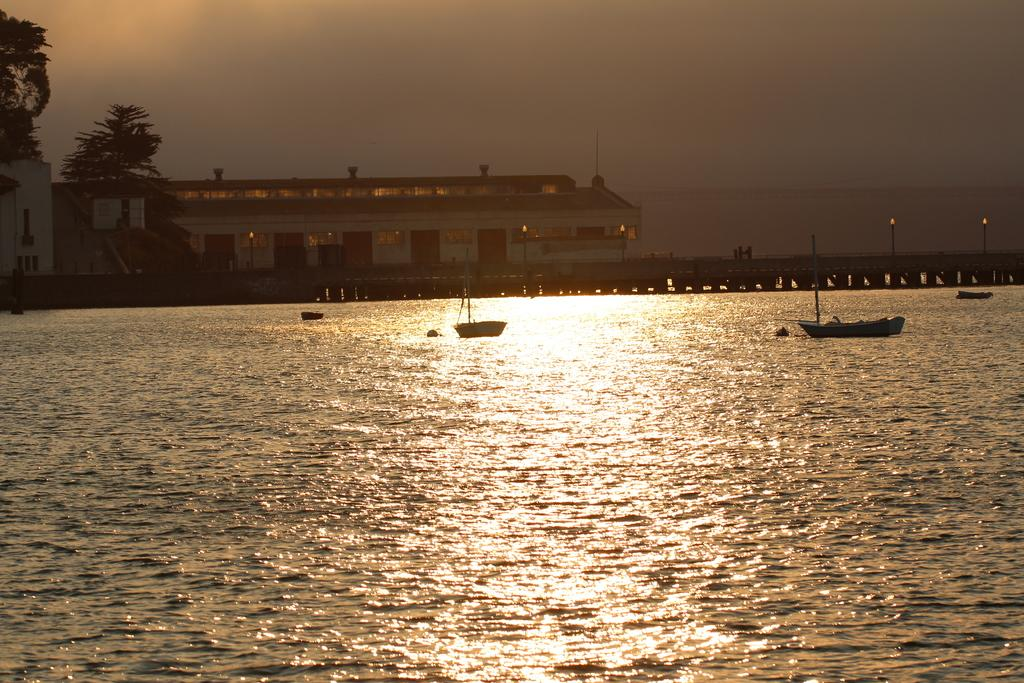What type of water body is visible in the image? There is a river in the image. What is on the river in the image? There are boats on the river. What can be seen in the background of the image? There is a building and trees in the background of the image. What part of the natural environment is visible in the image? The sky is visible in the background of the image. What type of toothbrush is being used by the donkey in the image? There is no donkey or toothbrush present in the image. 